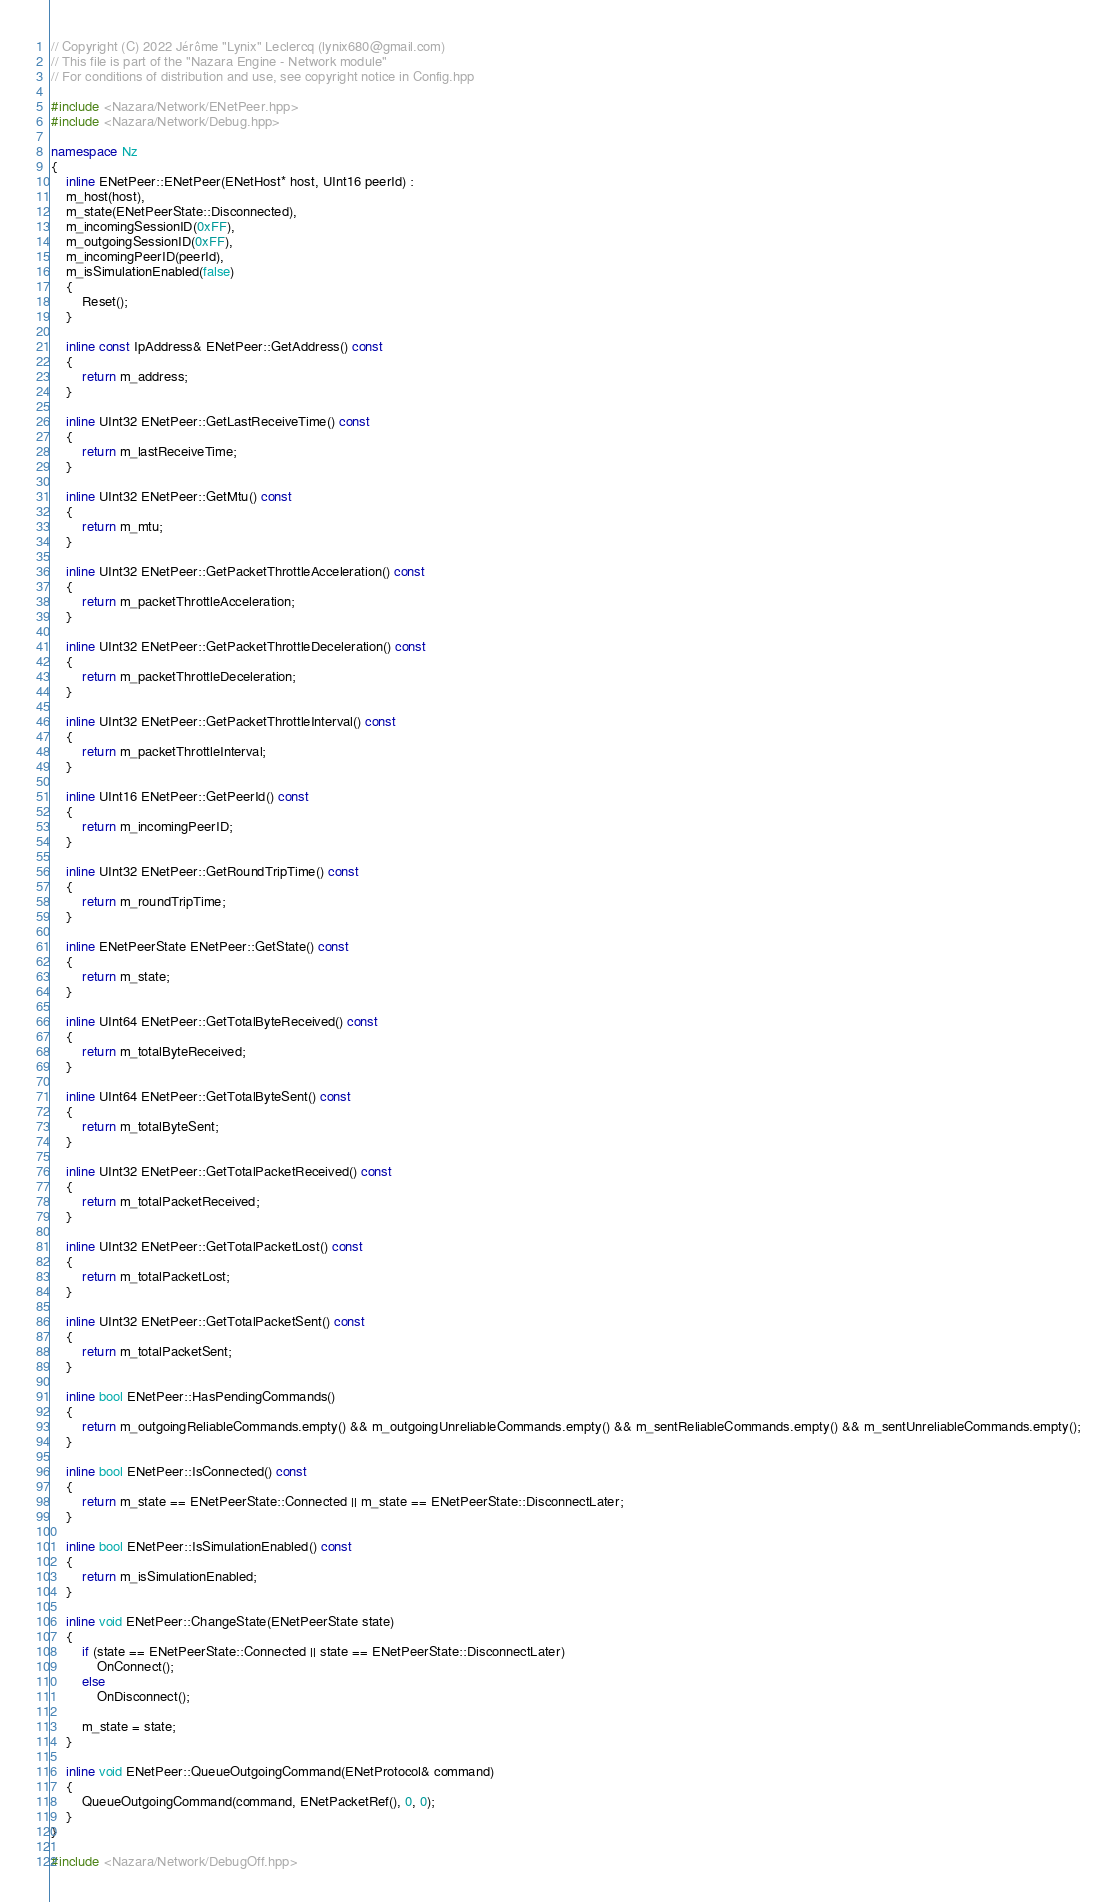<code> <loc_0><loc_0><loc_500><loc_500><_C++_>// Copyright (C) 2022 Jérôme "Lynix" Leclercq (lynix680@gmail.com)
// This file is part of the "Nazara Engine - Network module"
// For conditions of distribution and use, see copyright notice in Config.hpp

#include <Nazara/Network/ENetPeer.hpp>
#include <Nazara/Network/Debug.hpp>

namespace Nz
{
	inline ENetPeer::ENetPeer(ENetHost* host, UInt16 peerId) :
	m_host(host),
	m_state(ENetPeerState::Disconnected),
	m_incomingSessionID(0xFF),
	m_outgoingSessionID(0xFF),
	m_incomingPeerID(peerId),
	m_isSimulationEnabled(false)
	{
		Reset();
	}

	inline const IpAddress& ENetPeer::GetAddress() const
	{
		return m_address;
	}

	inline UInt32 ENetPeer::GetLastReceiveTime() const
	{
		return m_lastReceiveTime;
	}

	inline UInt32 ENetPeer::GetMtu() const
	{
		return m_mtu;
	}

	inline UInt32 ENetPeer::GetPacketThrottleAcceleration() const
	{
		return m_packetThrottleAcceleration;
	}

	inline UInt32 ENetPeer::GetPacketThrottleDeceleration() const
	{
		return m_packetThrottleDeceleration;
	}

	inline UInt32 ENetPeer::GetPacketThrottleInterval() const
	{
		return m_packetThrottleInterval;
	}

	inline UInt16 ENetPeer::GetPeerId() const
	{
		return m_incomingPeerID;
	}

	inline UInt32 ENetPeer::GetRoundTripTime() const
	{
		return m_roundTripTime;
	}

	inline ENetPeerState ENetPeer::GetState() const
	{
		return m_state;
	}

	inline UInt64 ENetPeer::GetTotalByteReceived() const
	{
		return m_totalByteReceived;
	}

	inline UInt64 ENetPeer::GetTotalByteSent() const
	{
		return m_totalByteSent;
	}

	inline UInt32 ENetPeer::GetTotalPacketReceived() const
	{
		return m_totalPacketReceived;
	}

	inline UInt32 ENetPeer::GetTotalPacketLost() const
	{
		return m_totalPacketLost;
	}

	inline UInt32 ENetPeer::GetTotalPacketSent() const
	{
		return m_totalPacketSent;
	}

	inline bool ENetPeer::HasPendingCommands()
	{
		return m_outgoingReliableCommands.empty() && m_outgoingUnreliableCommands.empty() && m_sentReliableCommands.empty() && m_sentUnreliableCommands.empty();
	}

	inline bool ENetPeer::IsConnected() const
	{
		return m_state == ENetPeerState::Connected || m_state == ENetPeerState::DisconnectLater;
	}

	inline bool ENetPeer::IsSimulationEnabled() const
	{
		return m_isSimulationEnabled;
	}

	inline void ENetPeer::ChangeState(ENetPeerState state)
	{
		if (state == ENetPeerState::Connected || state == ENetPeerState::DisconnectLater)
			OnConnect();
		else
			OnDisconnect();

		m_state = state;
	}

	inline void ENetPeer::QueueOutgoingCommand(ENetProtocol& command)
	{
		QueueOutgoingCommand(command, ENetPacketRef(), 0, 0);
	}
}

#include <Nazara/Network/DebugOff.hpp>
</code> 